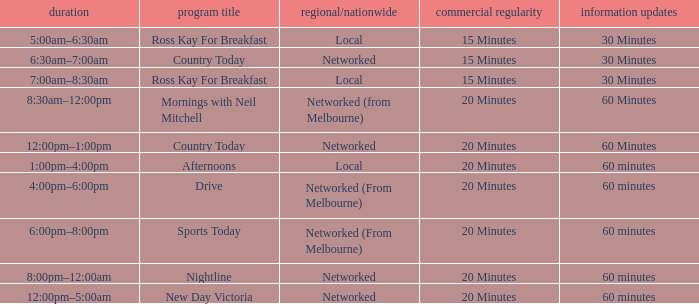What Time has a Show Name of mornings with neil mitchell? 8:30am–12:00pm. 